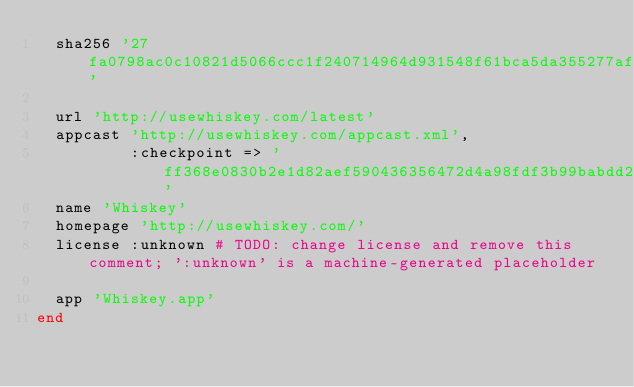Convert code to text. <code><loc_0><loc_0><loc_500><loc_500><_Ruby_>  sha256 '27fa0798ac0c10821d5066ccc1f240714964d931548f61bca5da355277af6402'

  url 'http://usewhiskey.com/latest'
  appcast 'http://usewhiskey.com/appcast.xml',
          :checkpoint => 'ff368e0830b2e1d82aef590436356472d4a98fdf3b99babdd2938cd128b05a00'
  name 'Whiskey'
  homepage 'http://usewhiskey.com/'
  license :unknown # TODO: change license and remove this comment; ':unknown' is a machine-generated placeholder

  app 'Whiskey.app'
end
</code> 